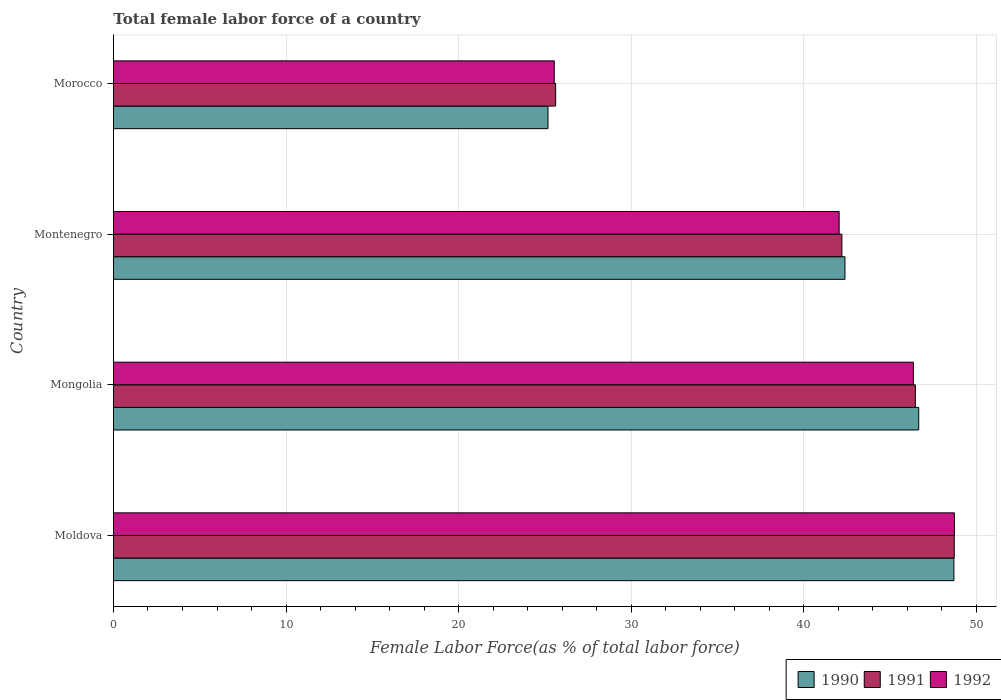How many different coloured bars are there?
Give a very brief answer. 3. Are the number of bars per tick equal to the number of legend labels?
Your answer should be very brief. Yes. Are the number of bars on each tick of the Y-axis equal?
Your answer should be compact. Yes. How many bars are there on the 3rd tick from the bottom?
Your response must be concise. 3. What is the label of the 4th group of bars from the top?
Give a very brief answer. Moldova. In how many cases, is the number of bars for a given country not equal to the number of legend labels?
Keep it short and to the point. 0. What is the percentage of female labor force in 1990 in Montenegro?
Provide a short and direct response. 42.39. Across all countries, what is the maximum percentage of female labor force in 1990?
Your response must be concise. 48.71. Across all countries, what is the minimum percentage of female labor force in 1990?
Provide a short and direct response. 25.18. In which country was the percentage of female labor force in 1990 maximum?
Make the answer very short. Moldova. In which country was the percentage of female labor force in 1991 minimum?
Your answer should be very brief. Morocco. What is the total percentage of female labor force in 1991 in the graph?
Your answer should be compact. 163.04. What is the difference between the percentage of female labor force in 1992 in Mongolia and that in Morocco?
Keep it short and to the point. 20.82. What is the difference between the percentage of female labor force in 1991 in Morocco and the percentage of female labor force in 1992 in Montenegro?
Your answer should be compact. -16.43. What is the average percentage of female labor force in 1991 per country?
Make the answer very short. 40.76. What is the difference between the percentage of female labor force in 1991 and percentage of female labor force in 1992 in Morocco?
Offer a very short reply. 0.08. In how many countries, is the percentage of female labor force in 1990 greater than 14 %?
Your answer should be very brief. 4. What is the ratio of the percentage of female labor force in 1992 in Moldova to that in Mongolia?
Give a very brief answer. 1.05. What is the difference between the highest and the second highest percentage of female labor force in 1991?
Keep it short and to the point. 2.25. What is the difference between the highest and the lowest percentage of female labor force in 1991?
Your answer should be compact. 23.1. What does the 3rd bar from the top in Montenegro represents?
Your response must be concise. 1990. Is it the case that in every country, the sum of the percentage of female labor force in 1992 and percentage of female labor force in 1991 is greater than the percentage of female labor force in 1990?
Ensure brevity in your answer.  Yes. Are all the bars in the graph horizontal?
Your answer should be compact. Yes. What is the title of the graph?
Your response must be concise. Total female labor force of a country. What is the label or title of the X-axis?
Offer a terse response. Female Labor Force(as % of total labor force). What is the label or title of the Y-axis?
Make the answer very short. Country. What is the Female Labor Force(as % of total labor force) of 1990 in Moldova?
Offer a terse response. 48.71. What is the Female Labor Force(as % of total labor force) of 1991 in Moldova?
Offer a terse response. 48.73. What is the Female Labor Force(as % of total labor force) of 1992 in Moldova?
Give a very brief answer. 48.74. What is the Female Labor Force(as % of total labor force) in 1990 in Mongolia?
Keep it short and to the point. 46.67. What is the Female Labor Force(as % of total labor force) of 1991 in Mongolia?
Keep it short and to the point. 46.47. What is the Female Labor Force(as % of total labor force) in 1992 in Mongolia?
Provide a succinct answer. 46.36. What is the Female Labor Force(as % of total labor force) of 1990 in Montenegro?
Your answer should be very brief. 42.39. What is the Female Labor Force(as % of total labor force) of 1991 in Montenegro?
Provide a short and direct response. 42.22. What is the Female Labor Force(as % of total labor force) of 1992 in Montenegro?
Give a very brief answer. 42.06. What is the Female Labor Force(as % of total labor force) in 1990 in Morocco?
Provide a short and direct response. 25.18. What is the Female Labor Force(as % of total labor force) of 1991 in Morocco?
Provide a succinct answer. 25.63. What is the Female Labor Force(as % of total labor force) in 1992 in Morocco?
Your response must be concise. 25.55. Across all countries, what is the maximum Female Labor Force(as % of total labor force) of 1990?
Offer a very short reply. 48.71. Across all countries, what is the maximum Female Labor Force(as % of total labor force) of 1991?
Your answer should be compact. 48.73. Across all countries, what is the maximum Female Labor Force(as % of total labor force) in 1992?
Provide a short and direct response. 48.74. Across all countries, what is the minimum Female Labor Force(as % of total labor force) in 1990?
Ensure brevity in your answer.  25.18. Across all countries, what is the minimum Female Labor Force(as % of total labor force) of 1991?
Your answer should be very brief. 25.63. Across all countries, what is the minimum Female Labor Force(as % of total labor force) of 1992?
Offer a terse response. 25.55. What is the total Female Labor Force(as % of total labor force) of 1990 in the graph?
Your answer should be compact. 162.95. What is the total Female Labor Force(as % of total labor force) in 1991 in the graph?
Offer a very short reply. 163.04. What is the total Female Labor Force(as % of total labor force) of 1992 in the graph?
Provide a succinct answer. 162.71. What is the difference between the Female Labor Force(as % of total labor force) in 1990 in Moldova and that in Mongolia?
Make the answer very short. 2.04. What is the difference between the Female Labor Force(as % of total labor force) of 1991 in Moldova and that in Mongolia?
Offer a terse response. 2.25. What is the difference between the Female Labor Force(as % of total labor force) in 1992 in Moldova and that in Mongolia?
Your answer should be compact. 2.38. What is the difference between the Female Labor Force(as % of total labor force) of 1990 in Moldova and that in Montenegro?
Your response must be concise. 6.31. What is the difference between the Female Labor Force(as % of total labor force) of 1991 in Moldova and that in Montenegro?
Make the answer very short. 6.51. What is the difference between the Female Labor Force(as % of total labor force) of 1992 in Moldova and that in Montenegro?
Your answer should be compact. 6.68. What is the difference between the Female Labor Force(as % of total labor force) in 1990 in Moldova and that in Morocco?
Offer a terse response. 23.53. What is the difference between the Female Labor Force(as % of total labor force) of 1991 in Moldova and that in Morocco?
Give a very brief answer. 23.1. What is the difference between the Female Labor Force(as % of total labor force) in 1992 in Moldova and that in Morocco?
Your answer should be very brief. 23.19. What is the difference between the Female Labor Force(as % of total labor force) of 1990 in Mongolia and that in Montenegro?
Give a very brief answer. 4.28. What is the difference between the Female Labor Force(as % of total labor force) of 1991 in Mongolia and that in Montenegro?
Offer a very short reply. 4.26. What is the difference between the Female Labor Force(as % of total labor force) in 1992 in Mongolia and that in Montenegro?
Give a very brief answer. 4.3. What is the difference between the Female Labor Force(as % of total labor force) of 1990 in Mongolia and that in Morocco?
Your response must be concise. 21.49. What is the difference between the Female Labor Force(as % of total labor force) in 1991 in Mongolia and that in Morocco?
Provide a short and direct response. 20.85. What is the difference between the Female Labor Force(as % of total labor force) of 1992 in Mongolia and that in Morocco?
Your response must be concise. 20.82. What is the difference between the Female Labor Force(as % of total labor force) in 1990 in Montenegro and that in Morocco?
Provide a succinct answer. 17.21. What is the difference between the Female Labor Force(as % of total labor force) of 1991 in Montenegro and that in Morocco?
Your response must be concise. 16.59. What is the difference between the Female Labor Force(as % of total labor force) of 1992 in Montenegro and that in Morocco?
Offer a terse response. 16.51. What is the difference between the Female Labor Force(as % of total labor force) in 1990 in Moldova and the Female Labor Force(as % of total labor force) in 1991 in Mongolia?
Keep it short and to the point. 2.23. What is the difference between the Female Labor Force(as % of total labor force) of 1990 in Moldova and the Female Labor Force(as % of total labor force) of 1992 in Mongolia?
Provide a succinct answer. 2.35. What is the difference between the Female Labor Force(as % of total labor force) of 1991 in Moldova and the Female Labor Force(as % of total labor force) of 1992 in Mongolia?
Provide a succinct answer. 2.37. What is the difference between the Female Labor Force(as % of total labor force) of 1990 in Moldova and the Female Labor Force(as % of total labor force) of 1991 in Montenegro?
Make the answer very short. 6.49. What is the difference between the Female Labor Force(as % of total labor force) in 1990 in Moldova and the Female Labor Force(as % of total labor force) in 1992 in Montenegro?
Your response must be concise. 6.65. What is the difference between the Female Labor Force(as % of total labor force) in 1991 in Moldova and the Female Labor Force(as % of total labor force) in 1992 in Montenegro?
Offer a very short reply. 6.67. What is the difference between the Female Labor Force(as % of total labor force) in 1990 in Moldova and the Female Labor Force(as % of total labor force) in 1991 in Morocco?
Give a very brief answer. 23.08. What is the difference between the Female Labor Force(as % of total labor force) of 1990 in Moldova and the Female Labor Force(as % of total labor force) of 1992 in Morocco?
Your response must be concise. 23.16. What is the difference between the Female Labor Force(as % of total labor force) of 1991 in Moldova and the Female Labor Force(as % of total labor force) of 1992 in Morocco?
Offer a very short reply. 23.18. What is the difference between the Female Labor Force(as % of total labor force) in 1990 in Mongolia and the Female Labor Force(as % of total labor force) in 1991 in Montenegro?
Keep it short and to the point. 4.45. What is the difference between the Female Labor Force(as % of total labor force) in 1990 in Mongolia and the Female Labor Force(as % of total labor force) in 1992 in Montenegro?
Keep it short and to the point. 4.61. What is the difference between the Female Labor Force(as % of total labor force) in 1991 in Mongolia and the Female Labor Force(as % of total labor force) in 1992 in Montenegro?
Give a very brief answer. 4.42. What is the difference between the Female Labor Force(as % of total labor force) in 1990 in Mongolia and the Female Labor Force(as % of total labor force) in 1991 in Morocco?
Your answer should be compact. 21.04. What is the difference between the Female Labor Force(as % of total labor force) of 1990 in Mongolia and the Female Labor Force(as % of total labor force) of 1992 in Morocco?
Your answer should be compact. 21.12. What is the difference between the Female Labor Force(as % of total labor force) of 1991 in Mongolia and the Female Labor Force(as % of total labor force) of 1992 in Morocco?
Keep it short and to the point. 20.93. What is the difference between the Female Labor Force(as % of total labor force) in 1990 in Montenegro and the Female Labor Force(as % of total labor force) in 1991 in Morocco?
Offer a terse response. 16.77. What is the difference between the Female Labor Force(as % of total labor force) in 1990 in Montenegro and the Female Labor Force(as % of total labor force) in 1992 in Morocco?
Make the answer very short. 16.85. What is the difference between the Female Labor Force(as % of total labor force) of 1991 in Montenegro and the Female Labor Force(as % of total labor force) of 1992 in Morocco?
Ensure brevity in your answer.  16.67. What is the average Female Labor Force(as % of total labor force) of 1990 per country?
Give a very brief answer. 40.74. What is the average Female Labor Force(as % of total labor force) in 1991 per country?
Give a very brief answer. 40.76. What is the average Female Labor Force(as % of total labor force) in 1992 per country?
Your answer should be very brief. 40.68. What is the difference between the Female Labor Force(as % of total labor force) of 1990 and Female Labor Force(as % of total labor force) of 1991 in Moldova?
Your answer should be very brief. -0.02. What is the difference between the Female Labor Force(as % of total labor force) of 1990 and Female Labor Force(as % of total labor force) of 1992 in Moldova?
Offer a very short reply. -0.03. What is the difference between the Female Labor Force(as % of total labor force) of 1991 and Female Labor Force(as % of total labor force) of 1992 in Moldova?
Offer a very short reply. -0.01. What is the difference between the Female Labor Force(as % of total labor force) in 1990 and Female Labor Force(as % of total labor force) in 1991 in Mongolia?
Keep it short and to the point. 0.19. What is the difference between the Female Labor Force(as % of total labor force) in 1990 and Female Labor Force(as % of total labor force) in 1992 in Mongolia?
Ensure brevity in your answer.  0.31. What is the difference between the Female Labor Force(as % of total labor force) in 1991 and Female Labor Force(as % of total labor force) in 1992 in Mongolia?
Keep it short and to the point. 0.11. What is the difference between the Female Labor Force(as % of total labor force) in 1990 and Female Labor Force(as % of total labor force) in 1991 in Montenegro?
Ensure brevity in your answer.  0.18. What is the difference between the Female Labor Force(as % of total labor force) in 1990 and Female Labor Force(as % of total labor force) in 1992 in Montenegro?
Provide a succinct answer. 0.33. What is the difference between the Female Labor Force(as % of total labor force) of 1991 and Female Labor Force(as % of total labor force) of 1992 in Montenegro?
Ensure brevity in your answer.  0.16. What is the difference between the Female Labor Force(as % of total labor force) of 1990 and Female Labor Force(as % of total labor force) of 1991 in Morocco?
Provide a short and direct response. -0.44. What is the difference between the Female Labor Force(as % of total labor force) in 1990 and Female Labor Force(as % of total labor force) in 1992 in Morocco?
Your response must be concise. -0.36. What is the difference between the Female Labor Force(as % of total labor force) in 1991 and Female Labor Force(as % of total labor force) in 1992 in Morocco?
Provide a succinct answer. 0.08. What is the ratio of the Female Labor Force(as % of total labor force) of 1990 in Moldova to that in Mongolia?
Your answer should be compact. 1.04. What is the ratio of the Female Labor Force(as % of total labor force) in 1991 in Moldova to that in Mongolia?
Keep it short and to the point. 1.05. What is the ratio of the Female Labor Force(as % of total labor force) in 1992 in Moldova to that in Mongolia?
Provide a short and direct response. 1.05. What is the ratio of the Female Labor Force(as % of total labor force) of 1990 in Moldova to that in Montenegro?
Give a very brief answer. 1.15. What is the ratio of the Female Labor Force(as % of total labor force) of 1991 in Moldova to that in Montenegro?
Your response must be concise. 1.15. What is the ratio of the Female Labor Force(as % of total labor force) in 1992 in Moldova to that in Montenegro?
Make the answer very short. 1.16. What is the ratio of the Female Labor Force(as % of total labor force) in 1990 in Moldova to that in Morocco?
Make the answer very short. 1.93. What is the ratio of the Female Labor Force(as % of total labor force) of 1991 in Moldova to that in Morocco?
Your response must be concise. 1.9. What is the ratio of the Female Labor Force(as % of total labor force) of 1992 in Moldova to that in Morocco?
Ensure brevity in your answer.  1.91. What is the ratio of the Female Labor Force(as % of total labor force) of 1990 in Mongolia to that in Montenegro?
Provide a succinct answer. 1.1. What is the ratio of the Female Labor Force(as % of total labor force) in 1991 in Mongolia to that in Montenegro?
Your answer should be compact. 1.1. What is the ratio of the Female Labor Force(as % of total labor force) in 1992 in Mongolia to that in Montenegro?
Provide a succinct answer. 1.1. What is the ratio of the Female Labor Force(as % of total labor force) of 1990 in Mongolia to that in Morocco?
Give a very brief answer. 1.85. What is the ratio of the Female Labor Force(as % of total labor force) of 1991 in Mongolia to that in Morocco?
Your response must be concise. 1.81. What is the ratio of the Female Labor Force(as % of total labor force) of 1992 in Mongolia to that in Morocco?
Your answer should be compact. 1.81. What is the ratio of the Female Labor Force(as % of total labor force) of 1990 in Montenegro to that in Morocco?
Provide a short and direct response. 1.68. What is the ratio of the Female Labor Force(as % of total labor force) in 1991 in Montenegro to that in Morocco?
Provide a succinct answer. 1.65. What is the ratio of the Female Labor Force(as % of total labor force) in 1992 in Montenegro to that in Morocco?
Give a very brief answer. 1.65. What is the difference between the highest and the second highest Female Labor Force(as % of total labor force) of 1990?
Give a very brief answer. 2.04. What is the difference between the highest and the second highest Female Labor Force(as % of total labor force) of 1991?
Your response must be concise. 2.25. What is the difference between the highest and the second highest Female Labor Force(as % of total labor force) in 1992?
Your response must be concise. 2.38. What is the difference between the highest and the lowest Female Labor Force(as % of total labor force) in 1990?
Your response must be concise. 23.53. What is the difference between the highest and the lowest Female Labor Force(as % of total labor force) of 1991?
Your answer should be compact. 23.1. What is the difference between the highest and the lowest Female Labor Force(as % of total labor force) in 1992?
Give a very brief answer. 23.19. 